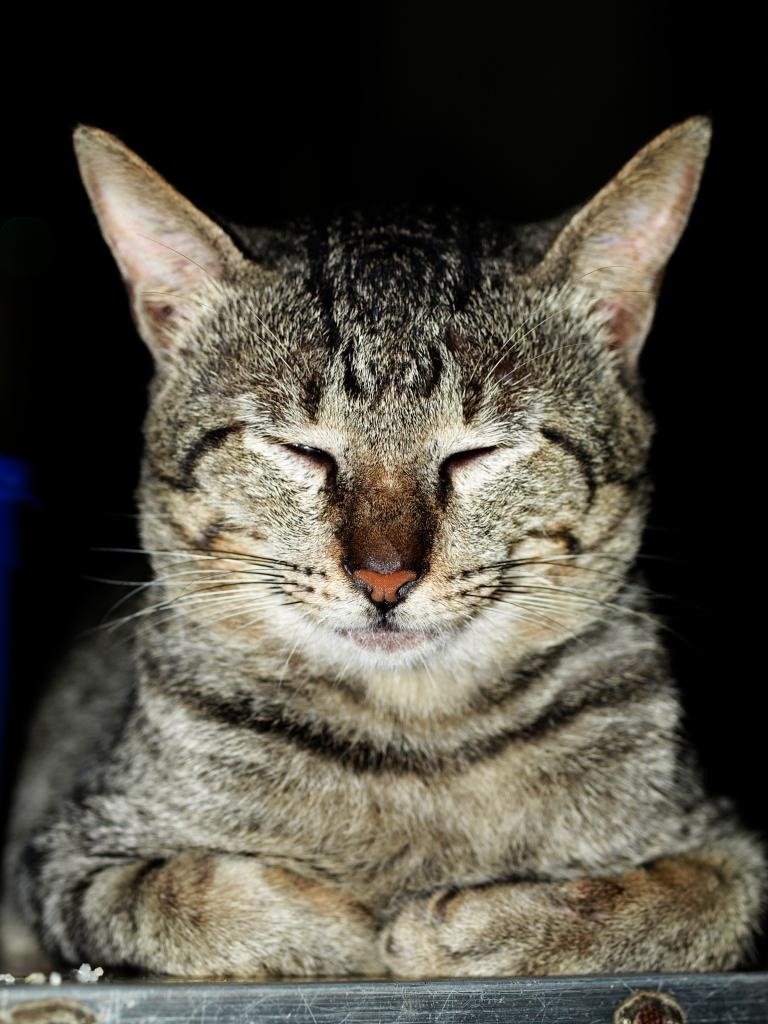What type of animal is in the image? There is a cat in the image. What historical event is depicted in the image involving the cat? There is no historical event depicted in the image; it simply features a cat. What type of flesh can be seen in the image? There is no flesh visible in the image; it only shows a cat. 